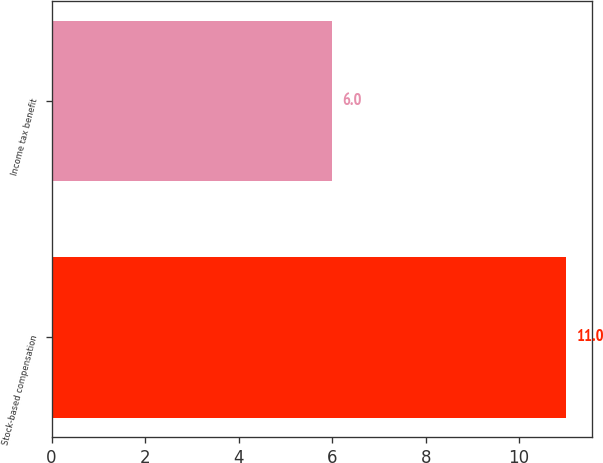Convert chart to OTSL. <chart><loc_0><loc_0><loc_500><loc_500><bar_chart><fcel>Stock-based compensation<fcel>Income tax benefit<nl><fcel>11<fcel>6<nl></chart> 